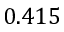<formula> <loc_0><loc_0><loc_500><loc_500>0 . 4 1 5</formula> 